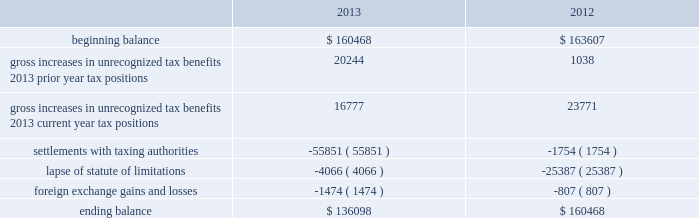Adobe systems incorporated notes to consolidated financial statements ( continued ) accounting for uncertainty in income taxes during fiscal 2013 and 2012 , our aggregate changes in our total gross amount of unrecognized tax benefits are summarized as follows ( in thousands ) : .
As of november 29 , 2013 , the combined amount of accrued interest and penalties related to tax positions taken on our tax returns and included in non-current income taxes payable was approximately $ 11.4 million .
We file income tax returns in the u.s .
On a federal basis and in many u.s .
State and foreign jurisdictions .
We are subject to the continual examination of our income tax returns by the irs and other domestic and foreign tax authorities .
Our major tax jurisdictions are the u.s. , ireland and california .
For california , ireland and the u.s. , the earliest fiscal years open for examination are 2005 , 2006 and 2010 , respectively .
We regularly assess the likelihood of outcomes resulting from these examinations to determine the adequacy of our provision for income taxes and have reserved for potential adjustments that may result from the current examinations .
We believe such estimates to be reasonable ; however , there can be no assurance that the final determination of any of these examinations will not have an adverse effect on our operating results and financial position .
In july 2013 , a u.s .
Income tax examination covering our fiscal years 2008 and 2009 was completed .
Our accrued tax and interest related to these years was $ 48.4 million and was previously reported in long-term income taxes payable .
We settled the tax obligation resulting from this examination with cash and income tax assets totaling $ 41.2 million , and the resulting $ 7.2 million income tax benefit was recorded in the third quarter of fiscal 2013 .
The timing of the resolution of income tax examinations is highly uncertain as are the amounts and timing of tax payments that are part of any audit settlement process .
These events could cause large fluctuations in the balance sheet classification of current and non-current assets and liabilities .
We believe that within the next 12 months , it is reasonably possible that either certain audits will conclude or statutes of limitations on certain income tax examination periods will expire , or both .
Given the uncertainties described above , we can only determine a range of estimated potential decreases in underlying unrecognized tax benefits ranging from $ 0 to approximately $ 5 million .
Note 10 .
Restructuring fiscal 2011 restructuring plan in the fourth quarter of fiscal 2011 , we initiated a restructuring plan consisting of reductions in workforce and the consolidation of facilities in order to better align our resources around our digital media and digital marketing strategies .
During fiscal 2013 , we continued to implement restructuring activities under this plan .
Total costs incurred to date and expected to be incurred for closing redundant facilities are $ 12.2 million as all facilities under this plan have been exited as of november 29 , 2013 .
Other restructuring plans other restructuring plans include other adobe plans and other plans associated with certain of our acquisitions that are substantially complete .
We continue to make cash outlays to settle obligations under these plans , however the current impact to our consolidated financial statements is not significant .
Our other restructuring plans primarily consist of the 2009 restructuring plan , which was implemented in the fourth quarter of fiscal 2009 , in order to appropriately align our costs in connection with our fiscal 2010 operating plan. .
What is the percentage change in total gross amount of unrecognized tax benefits from 2012 to 2013? 
Computations: ((136098 - 160468) / 160468)
Answer: -0.15187. Adobe systems incorporated notes to consolidated financial statements ( continued ) accounting for uncertainty in income taxes during fiscal 2013 and 2012 , our aggregate changes in our total gross amount of unrecognized tax benefits are summarized as follows ( in thousands ) : .
As of november 29 , 2013 , the combined amount of accrued interest and penalties related to tax positions taken on our tax returns and included in non-current income taxes payable was approximately $ 11.4 million .
We file income tax returns in the u.s .
On a federal basis and in many u.s .
State and foreign jurisdictions .
We are subject to the continual examination of our income tax returns by the irs and other domestic and foreign tax authorities .
Our major tax jurisdictions are the u.s. , ireland and california .
For california , ireland and the u.s. , the earliest fiscal years open for examination are 2005 , 2006 and 2010 , respectively .
We regularly assess the likelihood of outcomes resulting from these examinations to determine the adequacy of our provision for income taxes and have reserved for potential adjustments that may result from the current examinations .
We believe such estimates to be reasonable ; however , there can be no assurance that the final determination of any of these examinations will not have an adverse effect on our operating results and financial position .
In july 2013 , a u.s .
Income tax examination covering our fiscal years 2008 and 2009 was completed .
Our accrued tax and interest related to these years was $ 48.4 million and was previously reported in long-term income taxes payable .
We settled the tax obligation resulting from this examination with cash and income tax assets totaling $ 41.2 million , and the resulting $ 7.2 million income tax benefit was recorded in the third quarter of fiscal 2013 .
The timing of the resolution of income tax examinations is highly uncertain as are the amounts and timing of tax payments that are part of any audit settlement process .
These events could cause large fluctuations in the balance sheet classification of current and non-current assets and liabilities .
We believe that within the next 12 months , it is reasonably possible that either certain audits will conclude or statutes of limitations on certain income tax examination periods will expire , or both .
Given the uncertainties described above , we can only determine a range of estimated potential decreases in underlying unrecognized tax benefits ranging from $ 0 to approximately $ 5 million .
Note 10 .
Restructuring fiscal 2011 restructuring plan in the fourth quarter of fiscal 2011 , we initiated a restructuring plan consisting of reductions in workforce and the consolidation of facilities in order to better align our resources around our digital media and digital marketing strategies .
During fiscal 2013 , we continued to implement restructuring activities under this plan .
Total costs incurred to date and expected to be incurred for closing redundant facilities are $ 12.2 million as all facilities under this plan have been exited as of november 29 , 2013 .
Other restructuring plans other restructuring plans include other adobe plans and other plans associated with certain of our acquisitions that are substantially complete .
We continue to make cash outlays to settle obligations under these plans , however the current impact to our consolidated financial statements is not significant .
Our other restructuring plans primarily consist of the 2009 restructuring plan , which was implemented in the fourth quarter of fiscal 2009 , in order to appropriately align our costs in connection with our fiscal 2010 operating plan. .
What is the percentage change in total gross amount of unrecognized tax benefits from 2011 to 2012? 
Computations: ((160468 - 163607) / 163607)
Answer: -0.01919. 